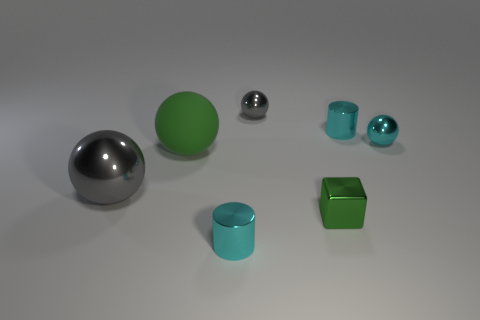Subtract all green matte spheres. How many spheres are left? 3 Subtract all green cylinders. How many gray spheres are left? 2 Add 3 cyan shiny objects. How many objects exist? 10 Subtract all green spheres. How many spheres are left? 3 Subtract 2 balls. How many balls are left? 2 Subtract all balls. How many objects are left? 3 Subtract all yellow balls. Subtract all blue cylinders. How many balls are left? 4 Subtract 0 yellow cylinders. How many objects are left? 7 Subtract all small gray shiny things. Subtract all metallic objects. How many objects are left? 0 Add 5 gray objects. How many gray objects are left? 7 